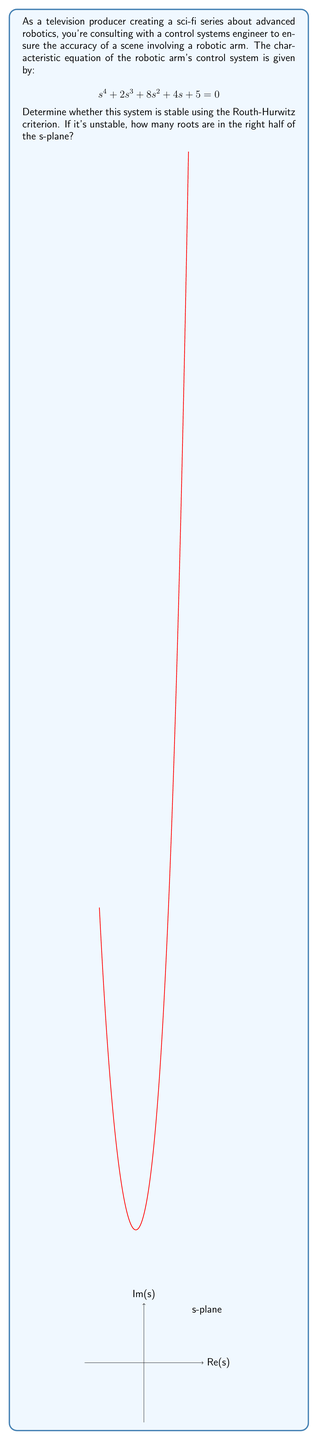Provide a solution to this math problem. Let's apply the Routh-Hurwitz criterion step-by-step:

1) First, we construct the Routh array:

   $$\begin{array}{c|c|c}
   s^4 & 1 & 8 & 5 \\
   s^3 & 2 & 4 & 0 \\
   s^2 & a & b & 0 \\
   s^1 & c & 0 & 0 \\
   s^0 & d & 0 & 0
   \end{array}$$

2) Calculate $a$:
   $$a = \frac{(2 \cdot 8) - (1 \cdot 4)}{2} = \frac{16 - 4}{2} = 6$$

3) Calculate $b$:
   $$b = \frac{(2 \cdot 5) - (1 \cdot 0)}{2} = 5$$

4) Calculate $c$:
   $$c = \frac{(6 \cdot 4) - (2 \cdot 5)}{6} = \frac{24 - 10}{6} = \frac{14}{6} = \frac{7}{3}$$

5) Calculate $d$:
   $$d = 5$$ (as it's the last element of the first column)

6) The complete Routh array:

   $$\begin{array}{c|c|c}
   s^4 & 1 & 8 & 5 \\
   s^3 & 2 & 4 & 0 \\
   s^2 & 6 & 5 & 0 \\
   s^1 & \frac{7}{3} & 0 & 0 \\
   s^0 & 5 & 0 & 0
   \end{array}$$

7) For stability, all elements in the first column must have the same sign. Here, they are all positive.

Therefore, the system is stable. There are no sign changes in the first column, so no roots are in the right half of the s-plane.
Answer: Stable, 0 roots in right half-plane 